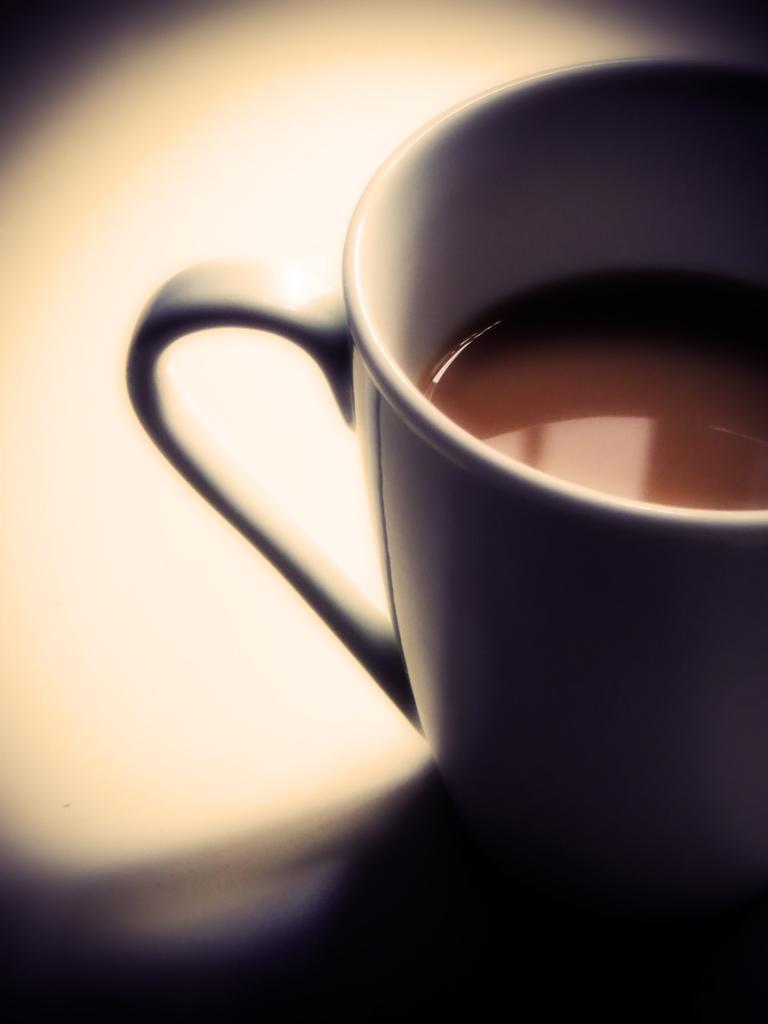In one or two sentences, can you explain what this image depicts? In this image I can see a teacup in white color. 